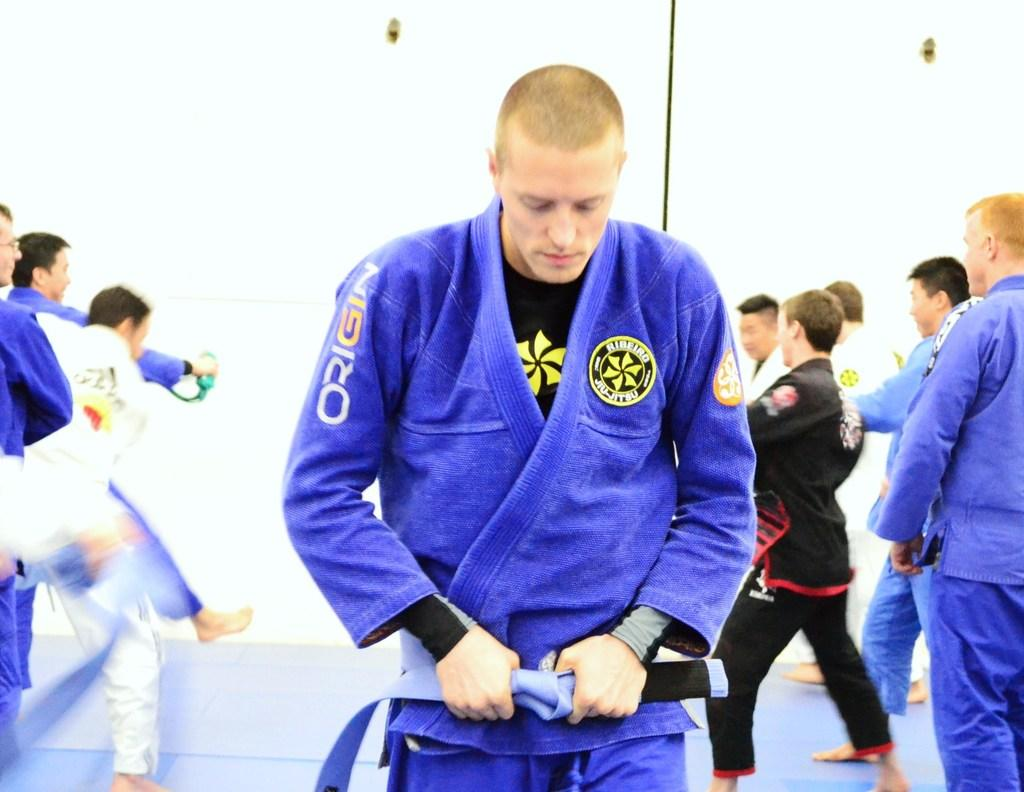<image>
Summarize the visual content of the image. A martial arts participant wears a robe by Origin. 